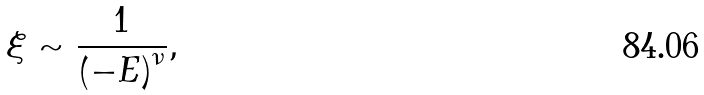Convert formula to latex. <formula><loc_0><loc_0><loc_500><loc_500>\xi \sim \frac { 1 } { \left ( - E \right ) ^ { \nu } } ,</formula> 